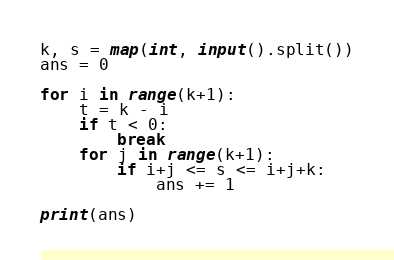Convert code to text. <code><loc_0><loc_0><loc_500><loc_500><_Python_>k, s = map(int, input().split())
ans = 0

for i in range(k+1):
    t = k - i
    if t < 0:
        break
    for j in range(k+1):
        if i+j <= s <= i+j+k:
            ans += 1

print(ans)</code> 